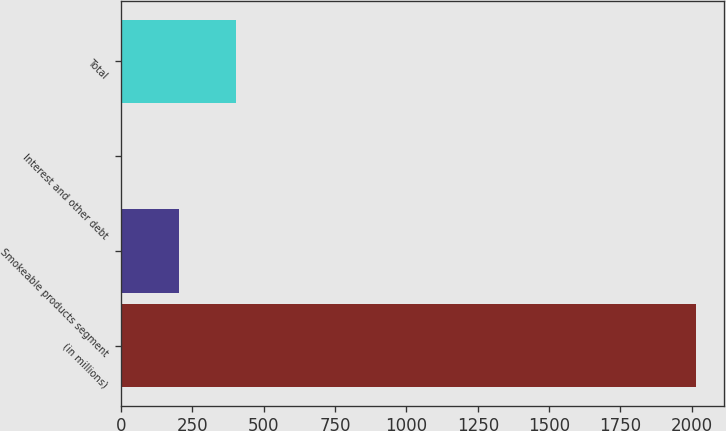<chart> <loc_0><loc_0><loc_500><loc_500><bar_chart><fcel>(in millions)<fcel>Smokeable products segment<fcel>Interest and other debt<fcel>Total<nl><fcel>2014<fcel>203.2<fcel>2<fcel>404.4<nl></chart> 